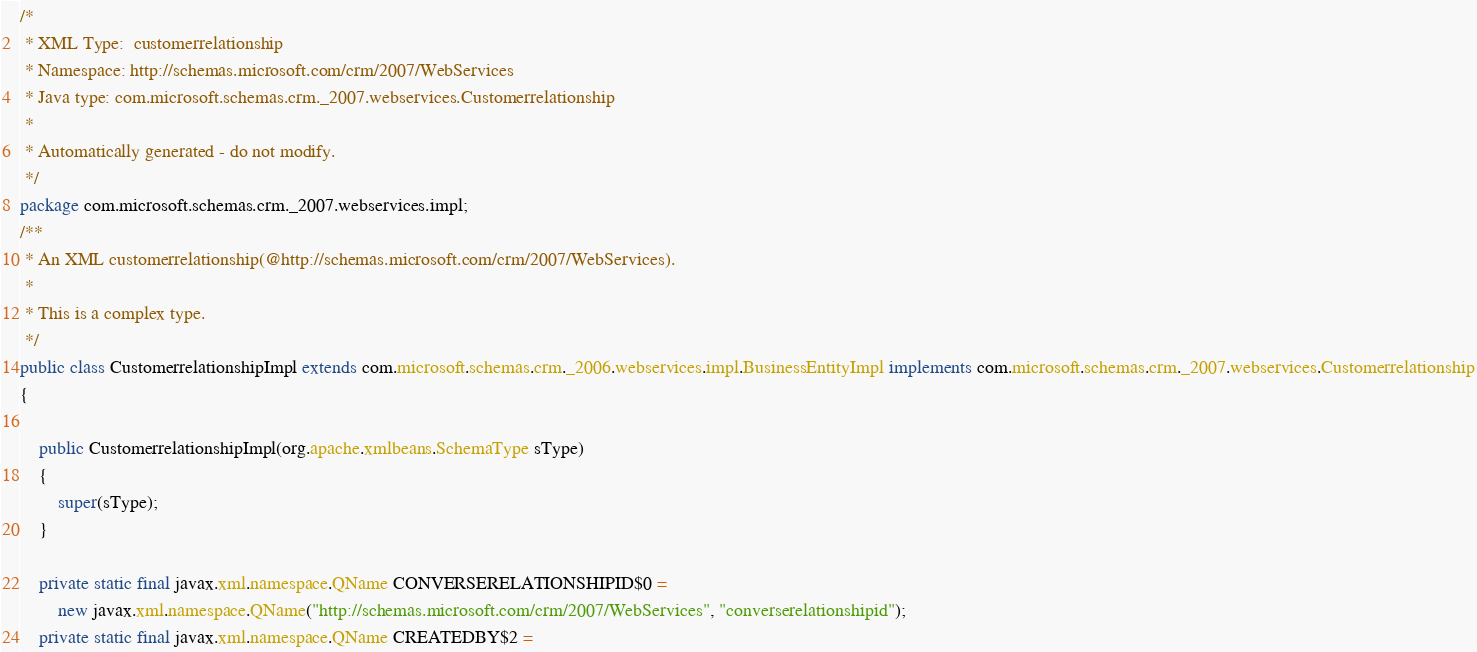<code> <loc_0><loc_0><loc_500><loc_500><_Java_>/*
 * XML Type:  customerrelationship
 * Namespace: http://schemas.microsoft.com/crm/2007/WebServices
 * Java type: com.microsoft.schemas.crm._2007.webservices.Customerrelationship
 *
 * Automatically generated - do not modify.
 */
package com.microsoft.schemas.crm._2007.webservices.impl;
/**
 * An XML customerrelationship(@http://schemas.microsoft.com/crm/2007/WebServices).
 *
 * This is a complex type.
 */
public class CustomerrelationshipImpl extends com.microsoft.schemas.crm._2006.webservices.impl.BusinessEntityImpl implements com.microsoft.schemas.crm._2007.webservices.Customerrelationship
{
    
    public CustomerrelationshipImpl(org.apache.xmlbeans.SchemaType sType)
    {
        super(sType);
    }
    
    private static final javax.xml.namespace.QName CONVERSERELATIONSHIPID$0 = 
        new javax.xml.namespace.QName("http://schemas.microsoft.com/crm/2007/WebServices", "converserelationshipid");
    private static final javax.xml.namespace.QName CREATEDBY$2 = </code> 